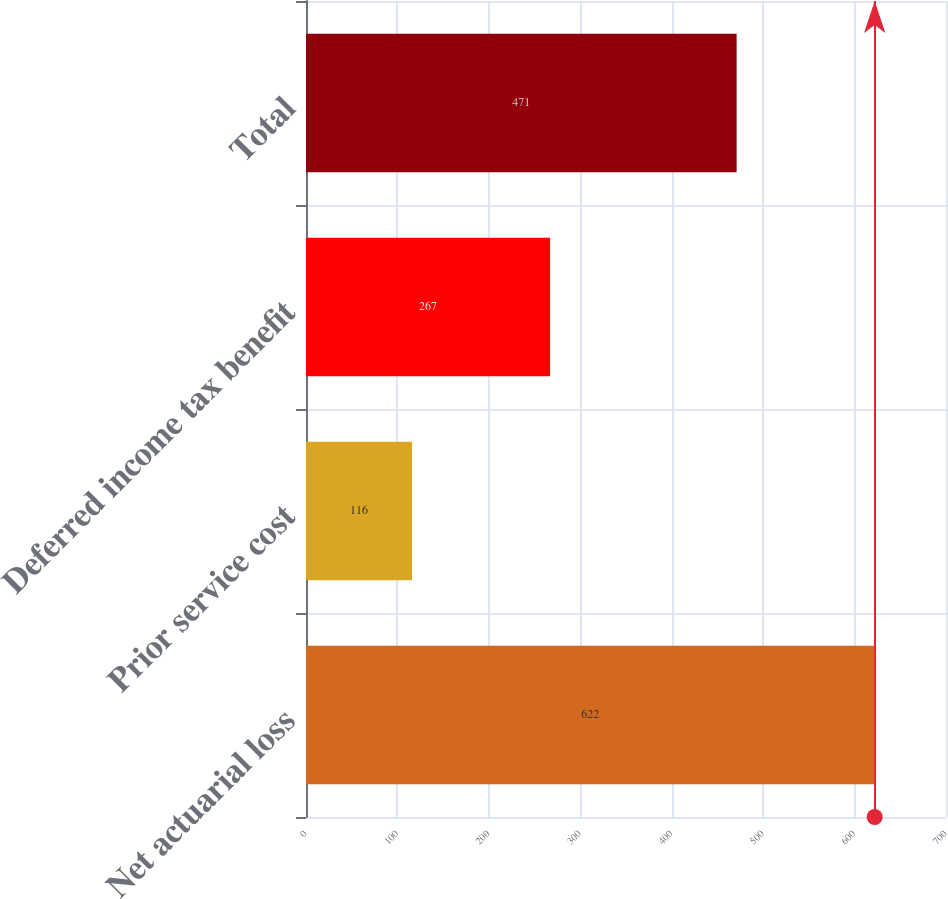Convert chart to OTSL. <chart><loc_0><loc_0><loc_500><loc_500><bar_chart><fcel>Net actuarial loss<fcel>Prior service cost<fcel>Deferred income tax benefit<fcel>Total<nl><fcel>622<fcel>116<fcel>267<fcel>471<nl></chart> 